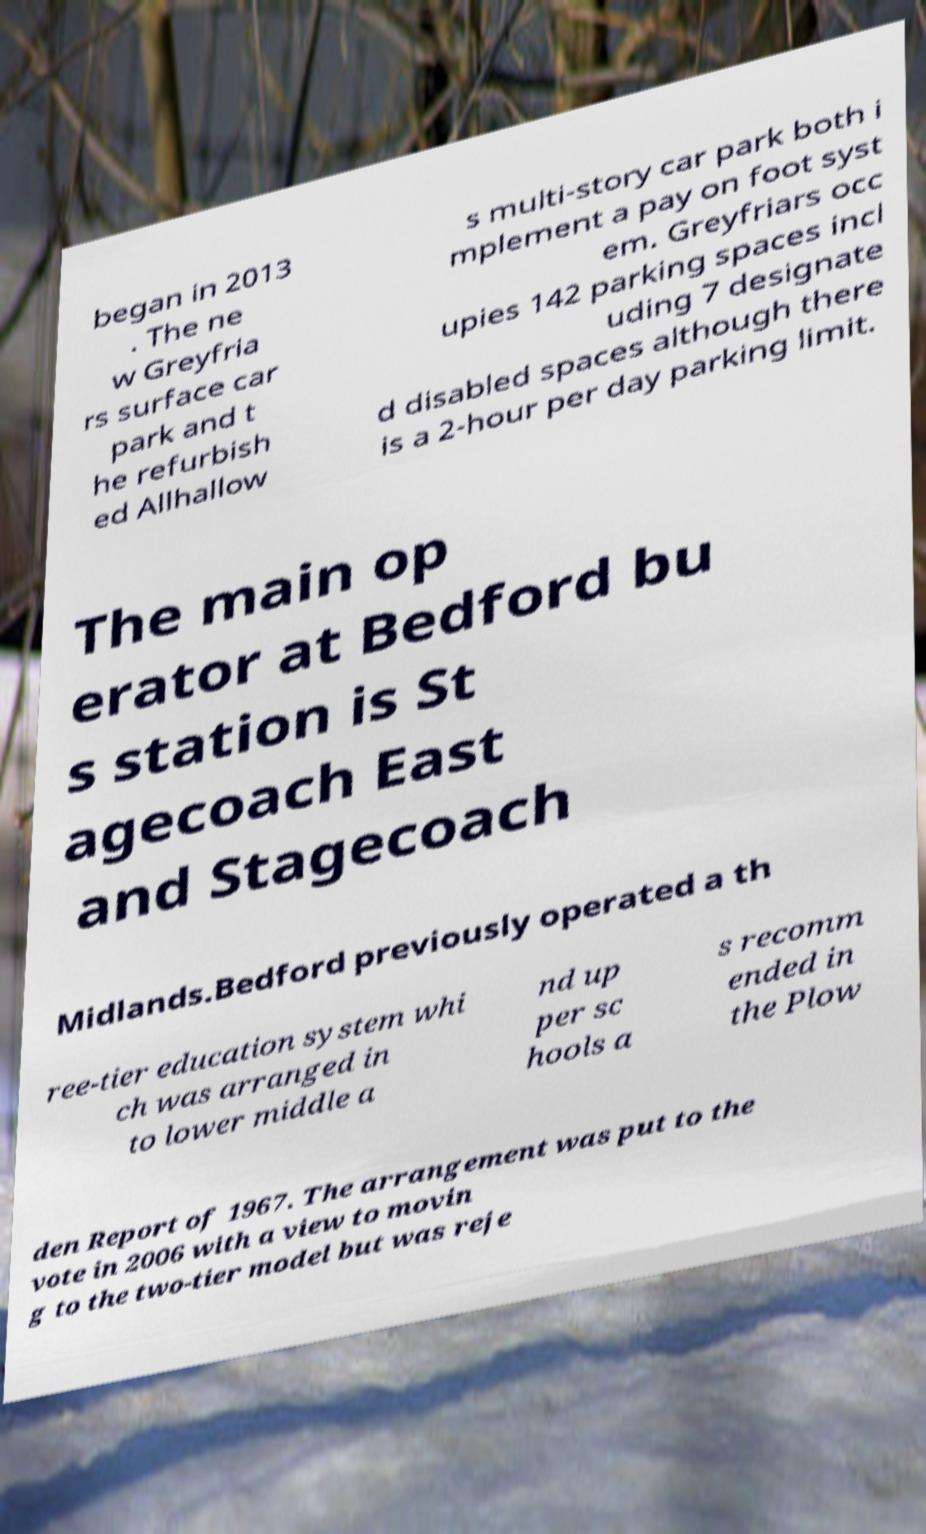What messages or text are displayed in this image? I need them in a readable, typed format. began in 2013 . The ne w Greyfria rs surface car park and t he refurbish ed Allhallow s multi-story car park both i mplement a pay on foot syst em. Greyfriars occ upies 142 parking spaces incl uding 7 designate d disabled spaces although there is a 2-hour per day parking limit. The main op erator at Bedford bu s station is St agecoach East and Stagecoach Midlands.Bedford previously operated a th ree-tier education system whi ch was arranged in to lower middle a nd up per sc hools a s recomm ended in the Plow den Report of 1967. The arrangement was put to the vote in 2006 with a view to movin g to the two-tier model but was reje 